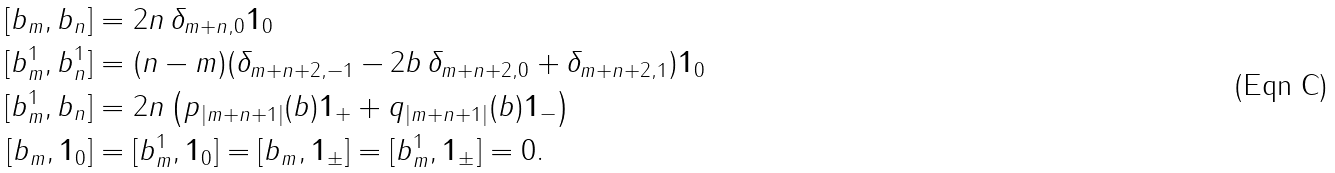Convert formula to latex. <formula><loc_0><loc_0><loc_500><loc_500>[ b _ { m } , b _ { n } ] & = 2 n \, \delta _ { m + n , 0 } \mathbf 1 _ { 0 } \\ [ b ^ { 1 } _ { m } , b _ { n } ^ { 1 } ] & = ( n - m ) ( \delta _ { m + n + 2 , - 1 } - 2 b \, \delta _ { m + n + 2 , 0 } + \delta _ { m + n + 2 , 1 } ) \mathbf 1 _ { 0 } \\ [ b ^ { 1 } _ { m } , b _ { n } ] & = 2 n \left ( p _ { | m + n + 1 | } ( b ) \mathbf 1 _ { + } + q _ { | m + n + 1 | } ( b ) \mathbf 1 _ { - } \right ) \\ [ b _ { m } , \mathbf 1 _ { 0 } ] & = [ b _ { m } ^ { 1 } , \mathbf 1 _ { 0 } ] = [ b _ { m } , \mathbf 1 _ { \pm } ] = [ b _ { m } ^ { 1 } , \mathbf 1 _ { \pm } ] = 0 .</formula> 